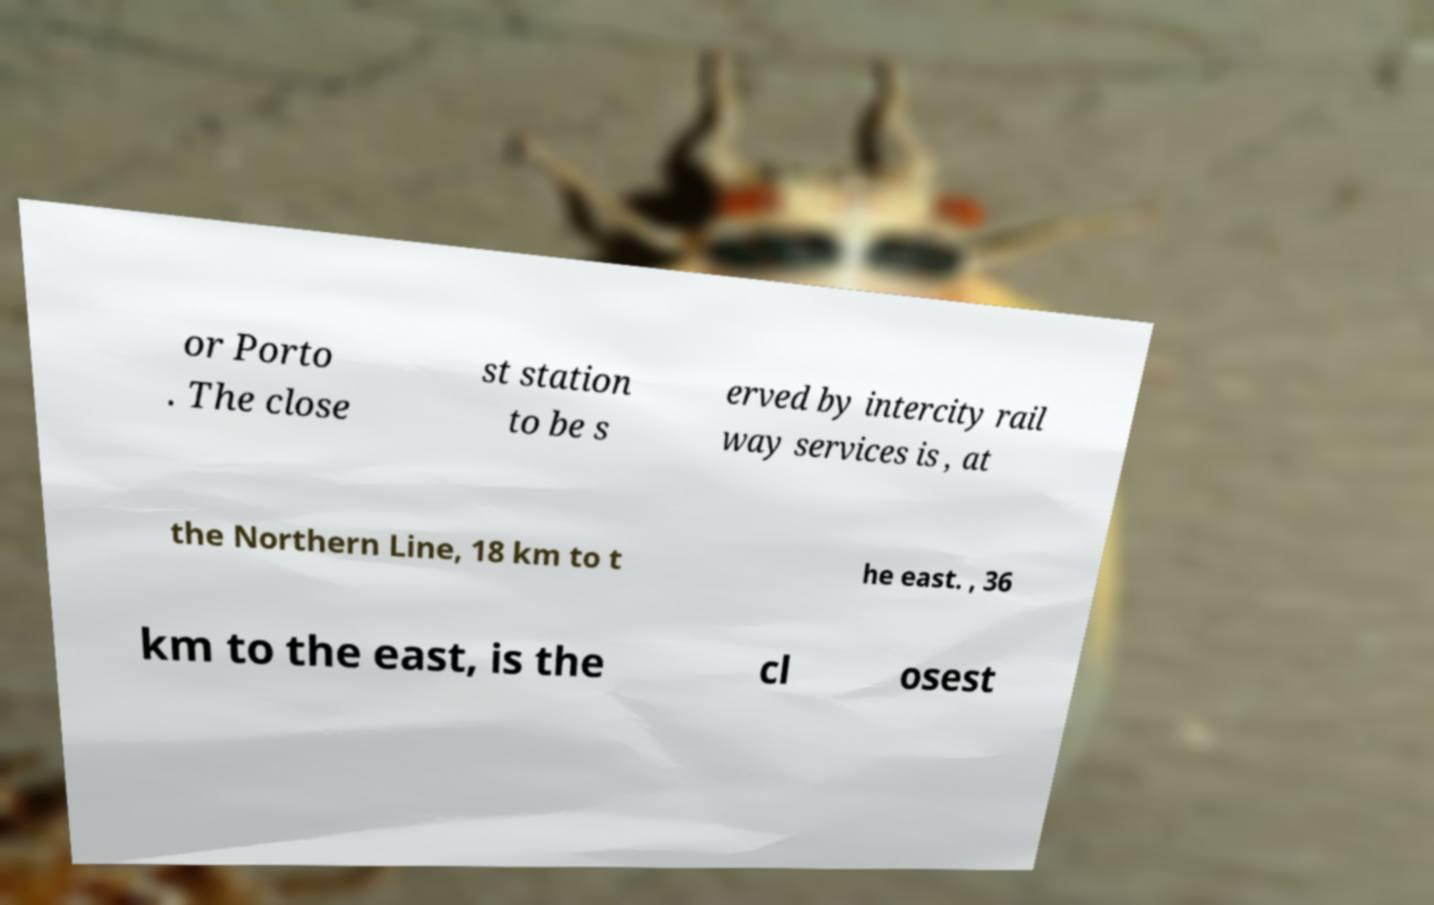Please identify and transcribe the text found in this image. or Porto . The close st station to be s erved by intercity rail way services is , at the Northern Line, 18 km to t he east. , 36 km to the east, is the cl osest 